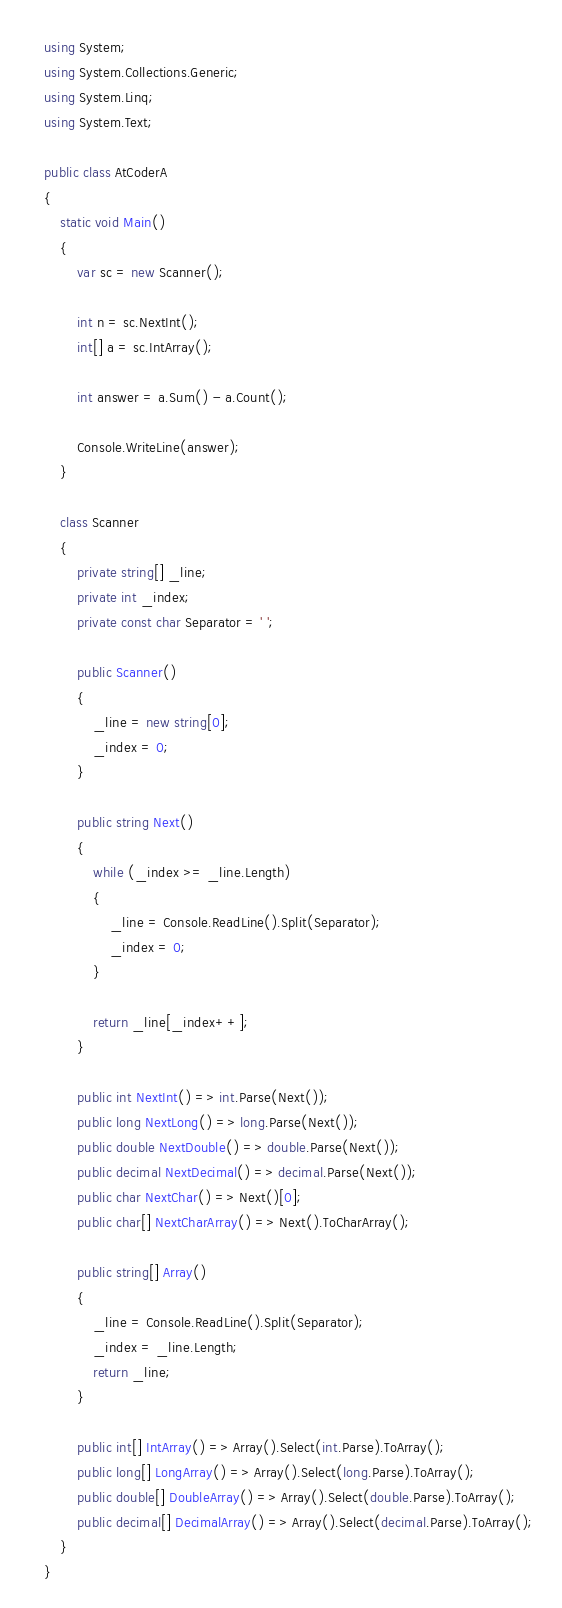<code> <loc_0><loc_0><loc_500><loc_500><_C#_>using System;
using System.Collections.Generic;
using System.Linq;
using System.Text;

public class AtCoderA
{
    static void Main()
    {
        var sc = new Scanner();

        int n = sc.NextInt();
        int[] a = sc.IntArray();

        int answer = a.Sum() - a.Count();

        Console.WriteLine(answer);
    }

    class Scanner
    {
        private string[] _line;
        private int _index;
        private const char Separator = ' ';

        public Scanner()
        {
            _line = new string[0];
            _index = 0;
        }

        public string Next()
        {
            while (_index >= _line.Length)
            {
                _line = Console.ReadLine().Split(Separator);
                _index = 0;
            }

            return _line[_index++];
        }

        public int NextInt() => int.Parse(Next());
        public long NextLong() => long.Parse(Next());
        public double NextDouble() => double.Parse(Next());
        public decimal NextDecimal() => decimal.Parse(Next());
        public char NextChar() => Next()[0];
        public char[] NextCharArray() => Next().ToCharArray();

        public string[] Array()
        {
            _line = Console.ReadLine().Split(Separator);
            _index = _line.Length;
            return _line;
        }

        public int[] IntArray() => Array().Select(int.Parse).ToArray();
        public long[] LongArray() => Array().Select(long.Parse).ToArray();
        public double[] DoubleArray() => Array().Select(double.Parse).ToArray();
        public decimal[] DecimalArray() => Array().Select(decimal.Parse).ToArray();
    }
}</code> 